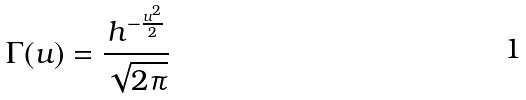<formula> <loc_0><loc_0><loc_500><loc_500>\Gamma ( u ) = \frac { h ^ { - \frac { u ^ { 2 } } { 2 } } } { \sqrt { 2 \pi } }</formula> 